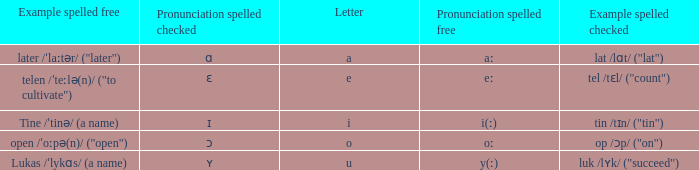What is Example Spelled Free, when Example Spelled Checked is "op /ɔp/ ("on")"? Open /ˈoːpə(n)/ ("open"). 